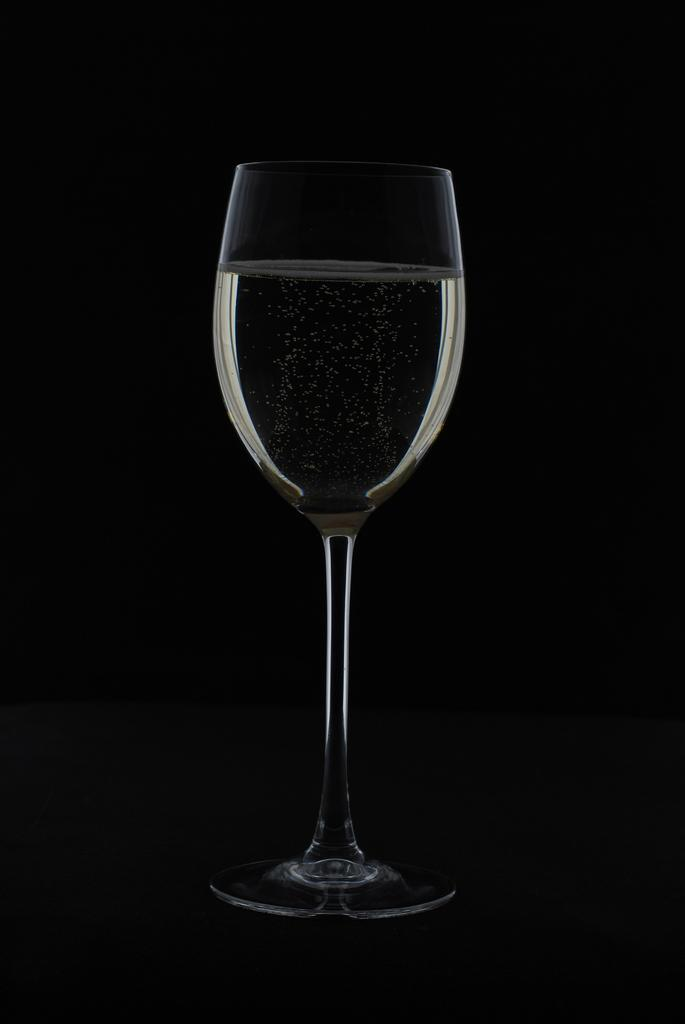What is in the glass that is visible in the center of the image? There is a glass of juice in the image. Where is the glass of juice located in the image? The glass of juice is in the center of the image. What type of music is being played in the background of the image? There is no music or background noise mentioned in the image, so it cannot be determined from the image. 